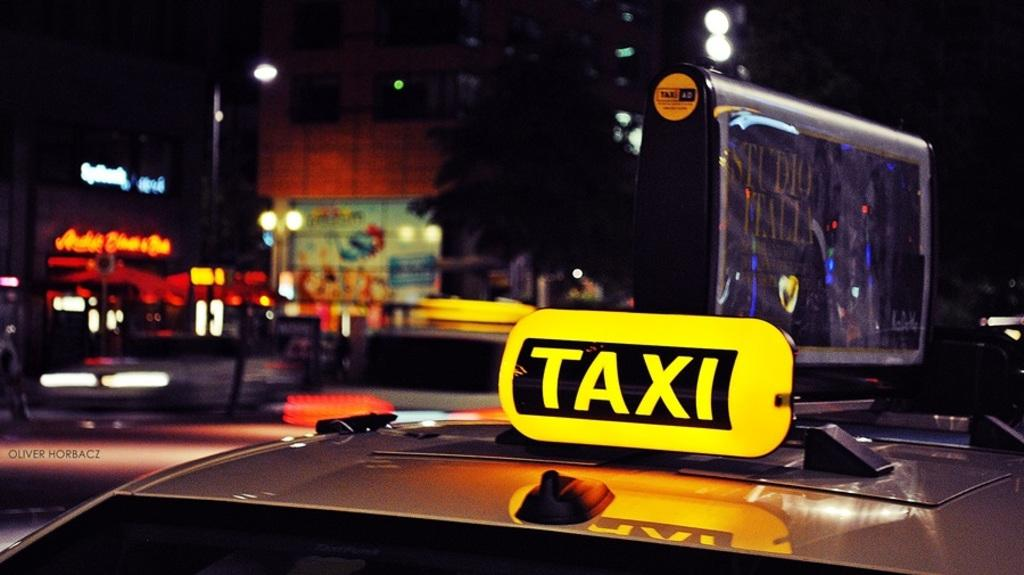<image>
Provide a brief description of the given image. A car with a yellow TAXI sign on top of it and a sign that says Studio Italia on it 